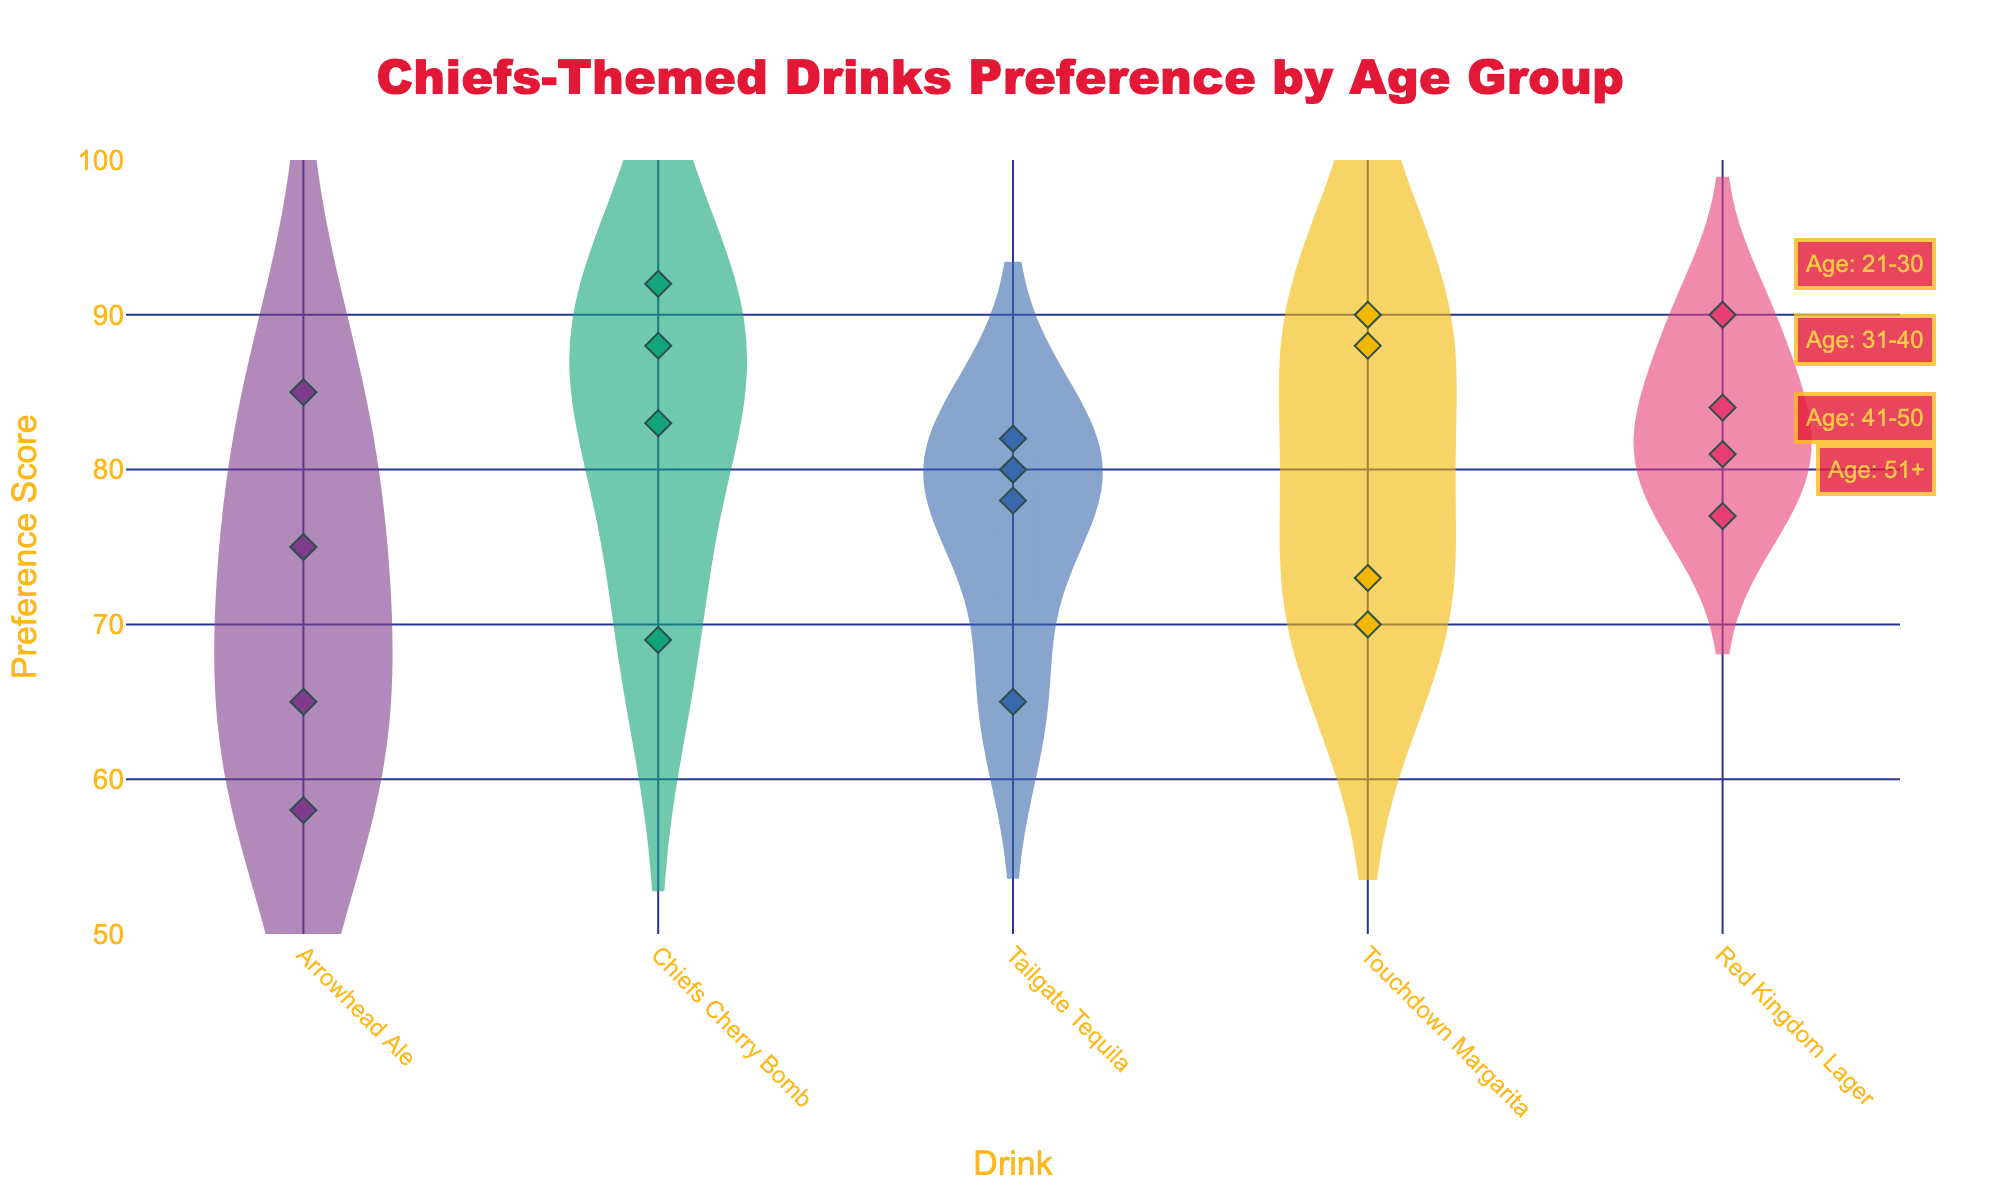What is the title of the figure? Look at the textual element at the top of the figure. The title provides a description of what the figure is about.
Answer: Chiefs-Themed Drinks Preference by Age Group Which drink has the highest mean preference score? The violin plots include a mean line. Identify the violin plot with the highest mean line.
Answer: Touchdown Margarita How many age groups are there in the figure? Look at the annotations or the different labels provided around the figure indicating distinct age group categories.
Answer: Four Which age group has the lowest preference score for Arrowhead Ale? Find the violin plot for Arrowhead Ale and check the scatter points. Identify the age group that has the scatter point with the lowest y-value.
Answer: Age 51+ Compare the preference scores of Chiefs Cherry Bomb and Touchdown Margarita. Which has a higher range of scores? Look at the width of the violin plots for both drinks. The one with the wider plot across the y-axis has a higher range of scores.
Answer: Touchdown Margarita What is the overall trend of preference scores across age groups for Red Kingdom Lager? Observe the scatter points for Red Kingdom Lager in all age groups and notice how the scores change from one age group to another. The analysis can discuss falling or rising trends.
Answer: Increasing What is the median preference score of Tailgate Tequila in the 31-40 age group? Within the violin plot for Tailgate Tequila, look for the central point where the scores are clustered in the 31-40 age group. The median is usually indicated by the thickest part of the violin where the highest density of points exists.
Answer: 82 Is there any drink that consistently ranks low across all age groups? Compare the mean lines and scatter points of each drink across all age groups to determine if there is a drink with consistently lower scores.
Answer: Arrowhead Ale Which age group shows the most variability in preference for Touchdown Margarita? Look at the width and spread of the Touchdown Margarita violin plot across different age groups. The group with the widest spread shows the most variability.
Answer: 41-50 How does the preference score for Chiefs Cherry Bomb vary by age group? Examine the scatter points and violin plots for Chiefs Cherry Bomb across the different age group annotations to describe the variability or stability in scores.
Answer: Decreases with age 